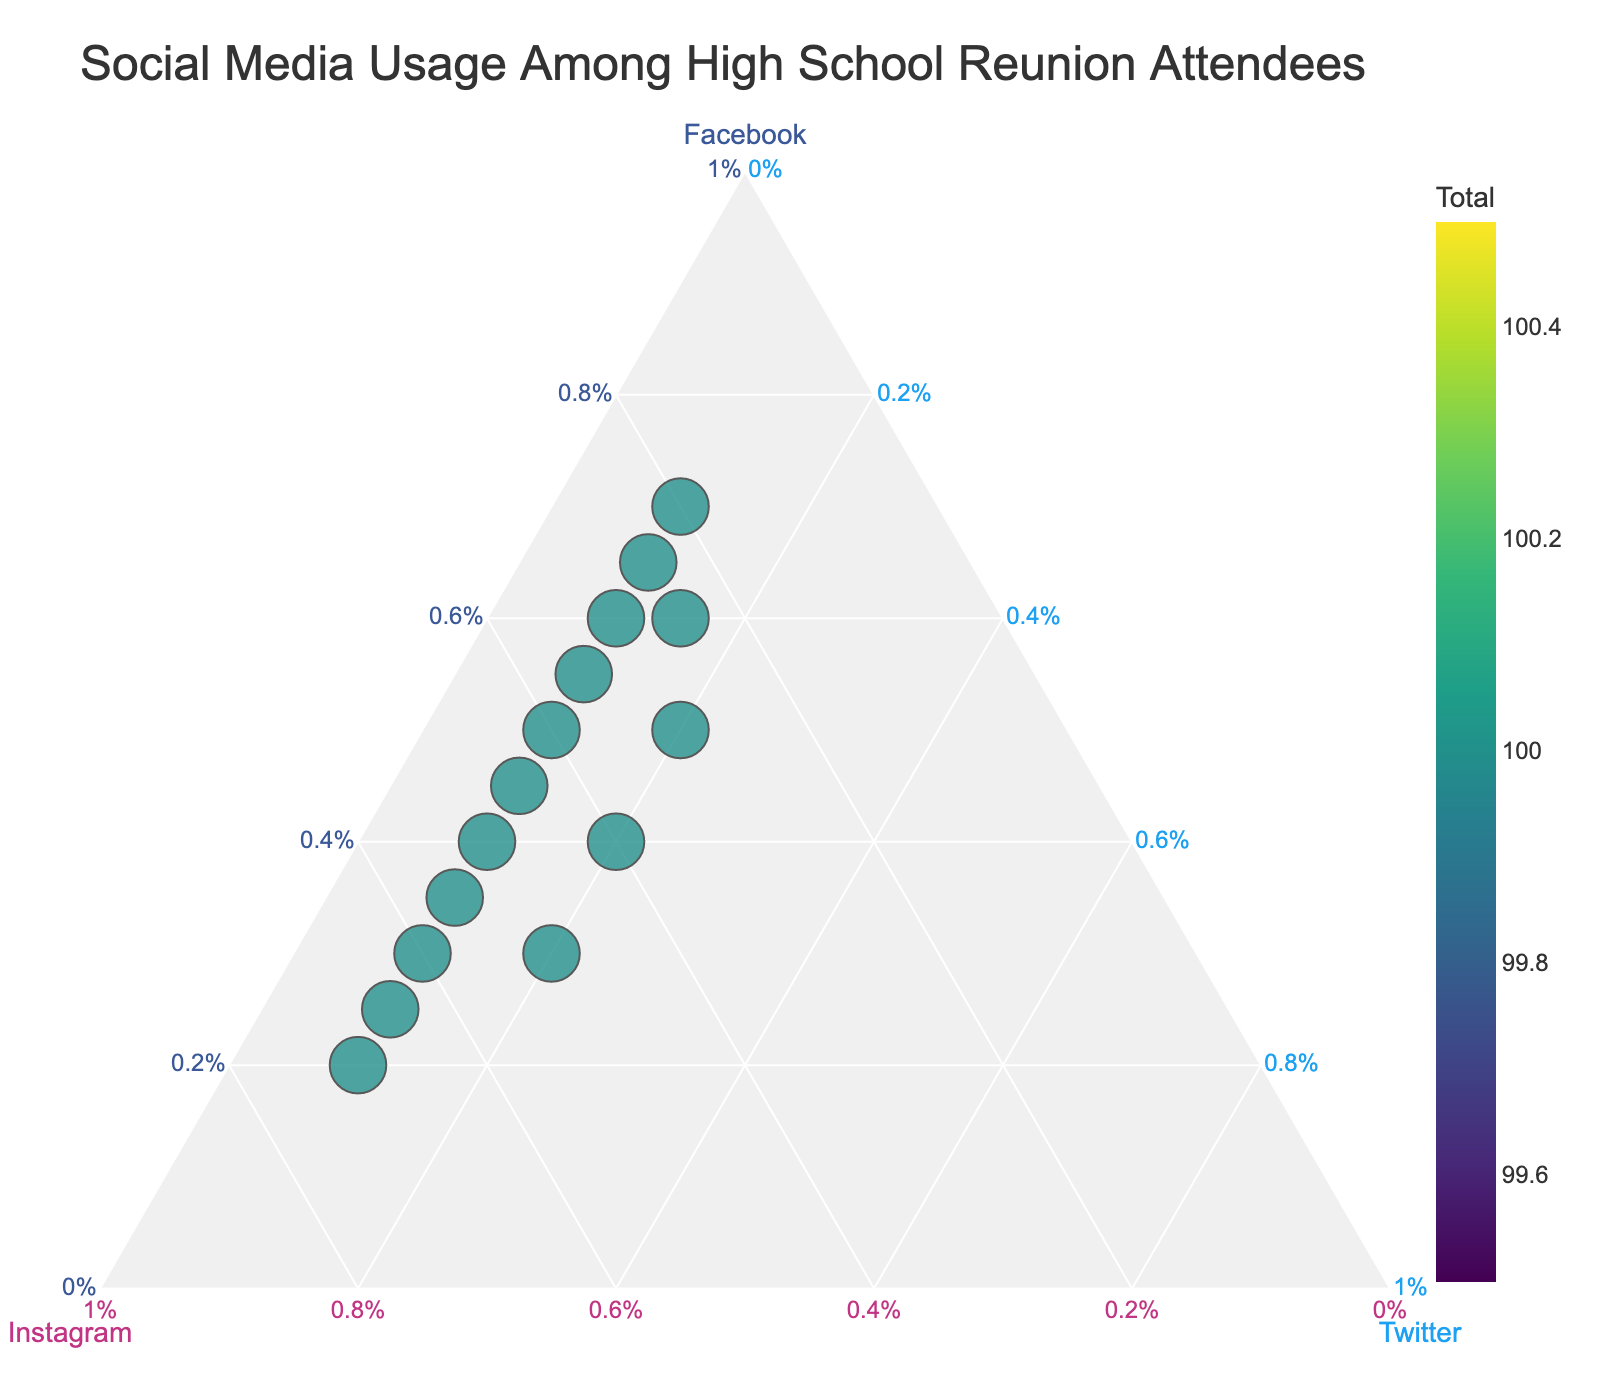What's the title of the figure? The title is displayed at the top of the figure in a large font size. It gives a brief description of what the figure is about.
Answer: Social Media Usage Among High School Reunion Attendees How many data points are shown in the ternary plot? By visually counting the number of points displayed on the ternary plot, you can see each individual's breakdown of social media usage.
Answer: 15 Which attendee uses Instagram the most? By looking at the axis labeled "Instagram" and identifying the data point closest to the Instagram corner, we can determine the attendee with the highest Instagram usage.
Answer: Jessica Brown How many attendees have more Facebook usage than Instagram usage? By comparing the positions of points along the Facebook and Instagram axes, you can count how many data points are closer to the Facebook axis corner compared to the Instagram axis corner.
Answer: 7 Which attendee has the most balanced usage among Facebook, Instagram, and Twitter? We look for the data point closest to the center of the ternary plot, indicating similar percentages of usage across all three platforms.
Answer: Rachel Taylor What's the average Twitter percentage among all attendees? Calculate Twitter percentages from the ternary plot, sum them up, and then divide by the total number of attendees to find the average.
Answer: 12.7% Which two attendees have the closest social media usage breakdowns? By identifying points that appear very close to each other on the ternary plot, we find attendees with similar social media usage breakdowns.
Answer: Sarah Johnson and Tom Rodriguez What is the range of Facebook usage percentages on the plot? Determine the minimum and maximum values of Facebook percentages on the plot and calculate the difference to find the range.
Answer: 20% to 70% Who has the highest total social media usage? By looking at the size of the markers (a larger size indicates higher total usage), identify the attendee with the largest marker.
Answer: Mike Thompson How many attendees have more than 50% of their social media usage on Instagram? By counting the points that are positioned closer to the Instagram axis corner, you can determine how many individuals fall into this category.
Answer: 5 